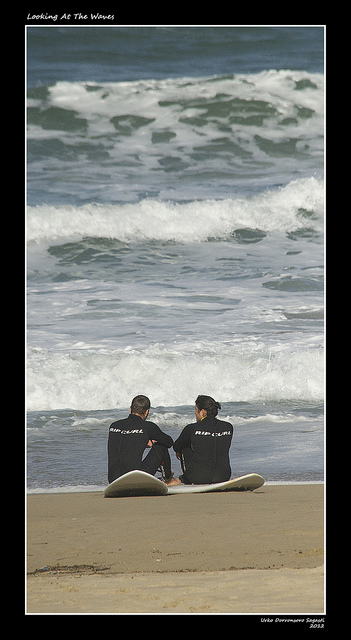Can you describe the weather conditions seen in the image? The weather seems fair, with no visible rain clouds, and the ocean's surface is moderately choppy, suggesting a gentle to moderate wind. Do the individuals look like they're having a conversation? While it's not possible to confirm if they're conversing, their relaxed posture and orientation toward each other could imply that they're engaged in a conversation. 